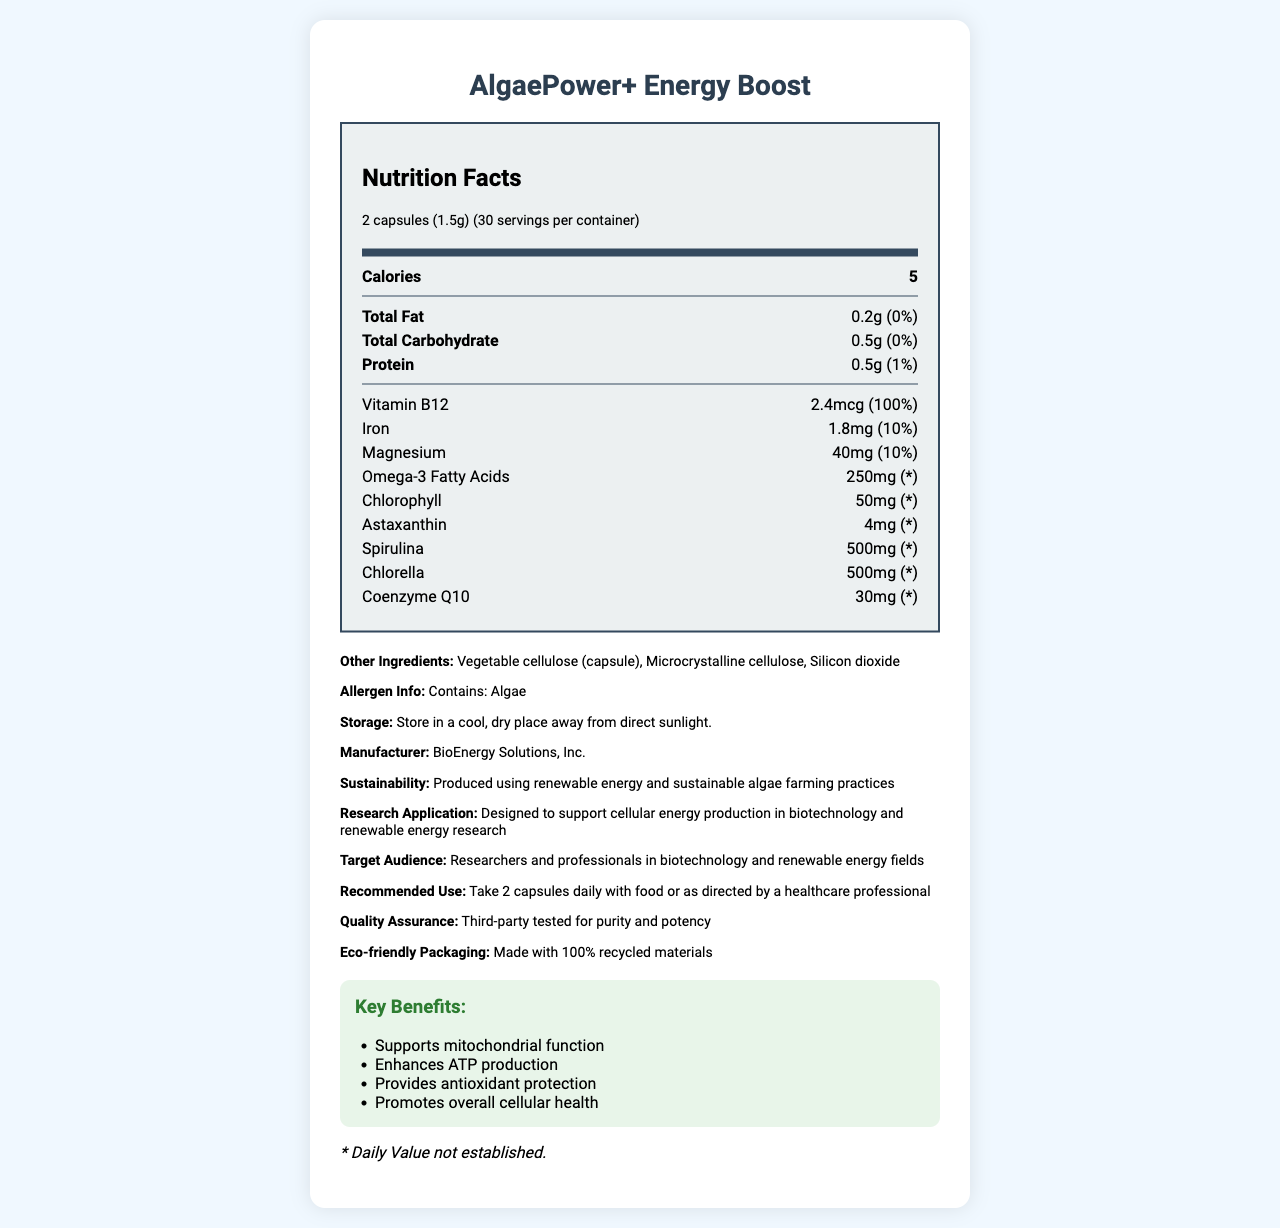Who is the target audience for AlgaePower+ Energy Boost? The document specifies that the target audience is researchers and professionals in the biotechnology and renewable energy fields.
Answer: Researchers and professionals in biotechnology and renewable energy fields What is the serving size for AlgaePower+ Energy Boost? The serving size is listed as 2 capsules, equivalent to 1.5 grams.
Answer: 2 capsules (1.5g) How many servings per container does AlgaePower+ Energy Boost have? The document states there are 30 servings per container.
Answer: 30 How many calories are in one serving of AlgaePower+ Energy Boost? The Nutrition Facts section lists the calorie count as 5 per serving.
Answer: 5 What percentage of the daily value for Vitamin B12 does AlgaePower+ Energy Boost provide? The Vitamin B12 content is listed as 2.4mcg, which is 100% of the daily value.
Answer: 100% How much Omega-3 Fatty Acids does one serving of AlgaePower+ Energy Boost contain? The amount of Omega-3 Fatty Acids per serving is listed as 250mg.
Answer: 250mg What are the main functions of AlgaePower+ Energy Boost according to the key benefits section? The key benefits section explicitly mentions these functions.
Answer: Supports mitochondrial function, enhances ATP production, provides antioxidant protection, promotes overall cellular health Which ingredient is not part of the product: A. Astaxanthin, B. Vitamin D, C. Coenzyme Q10 The listed ingredients include Astaxanthin and Coenzyme Q10, but Vitamin D is not included.
Answer: B. Vitamin D Which of the following is not mentioned as a benefit of using AlgaePower+ Energy Boost? I. Supporting mitochondrial function, II. Enhancing ATP production, III. Reducing cholesterol levels, IV. Providing antioxidant protection Benefits I, II, and IV are mentioned in the key benefits section, but reducing cholesterol levels is not.
Answer: III. Reducing cholesterol levels Is AlgaePower+ Energy Boost allergen-free? The allergen info clearly states that the product contains algae.
Answer: No Does the document provide details about the production and sustainability practices of AlgaePower+ Energy Boost? The document mentions that the product is produced using renewable energy and sustainable algae farming practices.
Answer: Yes What type of packaging is used for AlgaePower+ Energy Boost? The additional info section highlights that the packaging is made with 100% recycled materials.
Answer: Made with 100% recycled materials What is the manufacturer of AlgaePower+ Energy Boost? The manufacturer is listed as BioEnergy Solutions, Inc. in the additional information section.
Answer: BioEnergy Solutions, Inc. How should AlgaePower+ Energy Boost be stored? The storage instructions state to store it in a cool, dry place away from direct sunlight.
Answer: Store in a cool, dry place away from direct sunlight What is the main idea of the document? The document provides nutritional information, benefits, usage instructions, and other relevant details about the product, highlighting its application in renewable energy and biotechnology research.
Answer: AlgaePower+ Energy Boost is an algae-based supplement designed to support cellular energy production, with a focus on sustainability and use in biotechnology and renewable energy studies. It provides multiple health benefits and is intended for researchers and professionals in these fields. What is the specific format used for the document's presentation? The specific format used to present the document is not discernible from the content provided.
Answer: Not enough information 